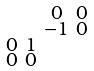<formula> <loc_0><loc_0><loc_500><loc_500>\begin{smallmatrix} & & 0 & 0 \\ & & - 1 & 0 \\ 0 & 1 & & \\ 0 & 0 & & \end{smallmatrix}</formula> 